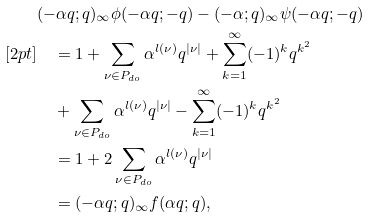<formula> <loc_0><loc_0><loc_500><loc_500>& ( - \alpha q ; q ) _ { \infty } \phi ( - \alpha q ; - q ) - ( - \alpha ; q ) _ { \infty } \psi ( - \alpha q ; - q ) \\ [ 2 p t ] & \quad = 1 + \sum _ { \nu \in P _ { d o } } \alpha ^ { l ( \nu ) } q ^ { | \nu | } + \sum _ { k = 1 } ^ { \infty } ( - 1 ) ^ { k } q ^ { k ^ { 2 } } \\ & \quad + \sum _ { \nu \in P _ { d o } } \alpha ^ { l ( \nu ) } q ^ { | \nu | } - \sum _ { k = 1 } ^ { \infty } ( - 1 ) ^ { k } q ^ { k ^ { 2 } } \\ & \quad = 1 + 2 \sum _ { \nu \in P _ { d o } } \alpha ^ { l ( \nu ) } q ^ { | \nu | } \\ & \quad = ( - \alpha q ; q ) _ { \infty } f ( \alpha q ; q ) ,</formula> 